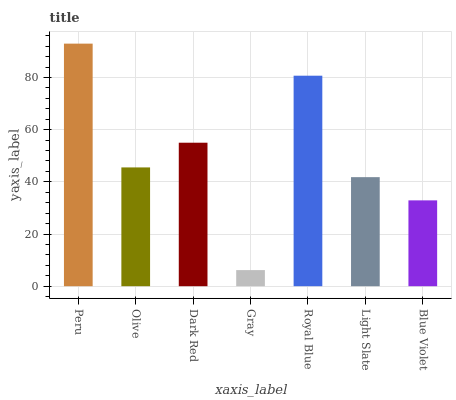Is Olive the minimum?
Answer yes or no. No. Is Olive the maximum?
Answer yes or no. No. Is Peru greater than Olive?
Answer yes or no. Yes. Is Olive less than Peru?
Answer yes or no. Yes. Is Olive greater than Peru?
Answer yes or no. No. Is Peru less than Olive?
Answer yes or no. No. Is Olive the high median?
Answer yes or no. Yes. Is Olive the low median?
Answer yes or no. Yes. Is Royal Blue the high median?
Answer yes or no. No. Is Peru the low median?
Answer yes or no. No. 